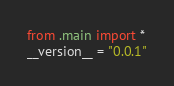Convert code to text. <code><loc_0><loc_0><loc_500><loc_500><_Python_>from .main import *
__version__ = "0.0.1"
</code> 